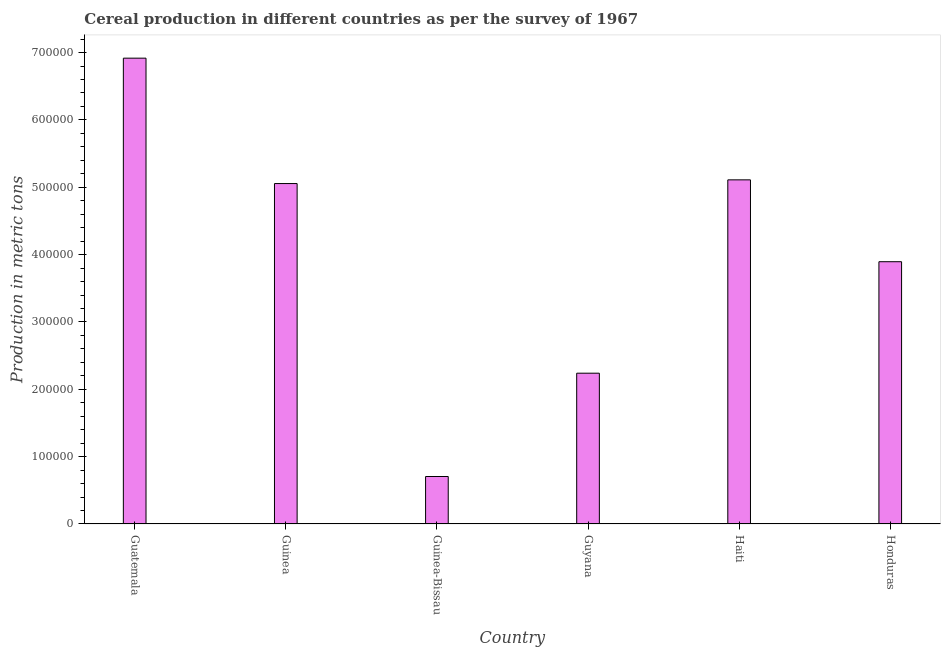Does the graph contain grids?
Offer a terse response. No. What is the title of the graph?
Ensure brevity in your answer.  Cereal production in different countries as per the survey of 1967. What is the label or title of the X-axis?
Provide a succinct answer. Country. What is the label or title of the Y-axis?
Provide a succinct answer. Production in metric tons. What is the cereal production in Honduras?
Your response must be concise. 3.89e+05. Across all countries, what is the maximum cereal production?
Make the answer very short. 6.92e+05. Across all countries, what is the minimum cereal production?
Offer a very short reply. 7.05e+04. In which country was the cereal production maximum?
Offer a very short reply. Guatemala. In which country was the cereal production minimum?
Offer a terse response. Guinea-Bissau. What is the sum of the cereal production?
Your response must be concise. 2.39e+06. What is the difference between the cereal production in Guinea and Haiti?
Your answer should be compact. -5510. What is the average cereal production per country?
Offer a very short reply. 3.99e+05. What is the median cereal production?
Your answer should be compact. 4.47e+05. In how many countries, is the cereal production greater than 640000 metric tons?
Ensure brevity in your answer.  1. What is the ratio of the cereal production in Guatemala to that in Honduras?
Make the answer very short. 1.78. Is the cereal production in Guatemala less than that in Haiti?
Your response must be concise. No. What is the difference between the highest and the second highest cereal production?
Provide a short and direct response. 1.81e+05. What is the difference between the highest and the lowest cereal production?
Make the answer very short. 6.21e+05. In how many countries, is the cereal production greater than the average cereal production taken over all countries?
Ensure brevity in your answer.  3. How many countries are there in the graph?
Provide a succinct answer. 6. Are the values on the major ticks of Y-axis written in scientific E-notation?
Offer a very short reply. No. What is the Production in metric tons in Guatemala?
Make the answer very short. 6.92e+05. What is the Production in metric tons of Guinea?
Your response must be concise. 5.05e+05. What is the Production in metric tons of Guinea-Bissau?
Provide a succinct answer. 7.05e+04. What is the Production in metric tons of Guyana?
Offer a terse response. 2.24e+05. What is the Production in metric tons in Haiti?
Your answer should be very brief. 5.11e+05. What is the Production in metric tons of Honduras?
Ensure brevity in your answer.  3.89e+05. What is the difference between the Production in metric tons in Guatemala and Guinea?
Keep it short and to the point. 1.86e+05. What is the difference between the Production in metric tons in Guatemala and Guinea-Bissau?
Keep it short and to the point. 6.21e+05. What is the difference between the Production in metric tons in Guatemala and Guyana?
Your answer should be compact. 4.68e+05. What is the difference between the Production in metric tons in Guatemala and Haiti?
Offer a very short reply. 1.81e+05. What is the difference between the Production in metric tons in Guatemala and Honduras?
Make the answer very short. 3.02e+05. What is the difference between the Production in metric tons in Guinea and Guinea-Bissau?
Provide a succinct answer. 4.35e+05. What is the difference between the Production in metric tons in Guinea and Guyana?
Your answer should be compact. 2.82e+05. What is the difference between the Production in metric tons in Guinea and Haiti?
Provide a succinct answer. -5510. What is the difference between the Production in metric tons in Guinea and Honduras?
Keep it short and to the point. 1.16e+05. What is the difference between the Production in metric tons in Guinea-Bissau and Guyana?
Make the answer very short. -1.53e+05. What is the difference between the Production in metric tons in Guinea-Bissau and Haiti?
Your response must be concise. -4.40e+05. What is the difference between the Production in metric tons in Guinea-Bissau and Honduras?
Your answer should be compact. -3.19e+05. What is the difference between the Production in metric tons in Guyana and Haiti?
Make the answer very short. -2.87e+05. What is the difference between the Production in metric tons in Guyana and Honduras?
Keep it short and to the point. -1.66e+05. What is the difference between the Production in metric tons in Haiti and Honduras?
Your answer should be very brief. 1.22e+05. What is the ratio of the Production in metric tons in Guatemala to that in Guinea?
Ensure brevity in your answer.  1.37. What is the ratio of the Production in metric tons in Guatemala to that in Guinea-Bissau?
Your answer should be compact. 9.81. What is the ratio of the Production in metric tons in Guatemala to that in Guyana?
Offer a very short reply. 3.09. What is the ratio of the Production in metric tons in Guatemala to that in Haiti?
Give a very brief answer. 1.35. What is the ratio of the Production in metric tons in Guatemala to that in Honduras?
Provide a short and direct response. 1.78. What is the ratio of the Production in metric tons in Guinea to that in Guinea-Bissau?
Your answer should be compact. 7.17. What is the ratio of the Production in metric tons in Guinea to that in Guyana?
Provide a short and direct response. 2.26. What is the ratio of the Production in metric tons in Guinea to that in Haiti?
Keep it short and to the point. 0.99. What is the ratio of the Production in metric tons in Guinea to that in Honduras?
Your response must be concise. 1.3. What is the ratio of the Production in metric tons in Guinea-Bissau to that in Guyana?
Your response must be concise. 0.32. What is the ratio of the Production in metric tons in Guinea-Bissau to that in Haiti?
Provide a succinct answer. 0.14. What is the ratio of the Production in metric tons in Guinea-Bissau to that in Honduras?
Ensure brevity in your answer.  0.18. What is the ratio of the Production in metric tons in Guyana to that in Haiti?
Give a very brief answer. 0.44. What is the ratio of the Production in metric tons in Guyana to that in Honduras?
Provide a short and direct response. 0.57. What is the ratio of the Production in metric tons in Haiti to that in Honduras?
Ensure brevity in your answer.  1.31. 